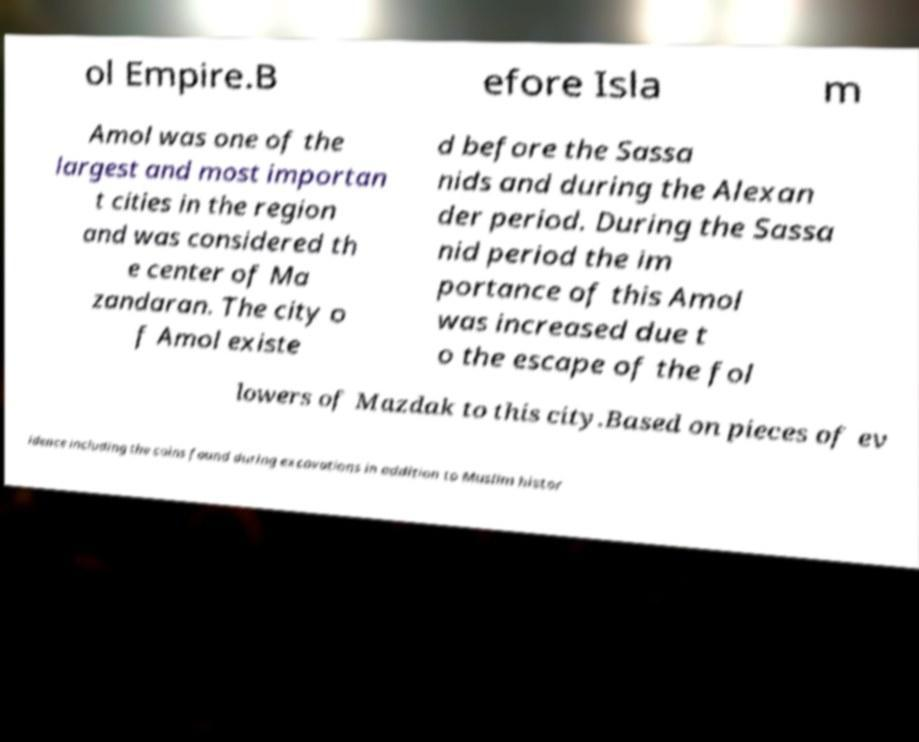I need the written content from this picture converted into text. Can you do that? ol Empire.B efore Isla m Amol was one of the largest and most importan t cities in the region and was considered th e center of Ma zandaran. The city o f Amol existe d before the Sassa nids and during the Alexan der period. During the Sassa nid period the im portance of this Amol was increased due t o the escape of the fol lowers of Mazdak to this city.Based on pieces of ev idence including the coins found during excavations in addition to Muslim histor 